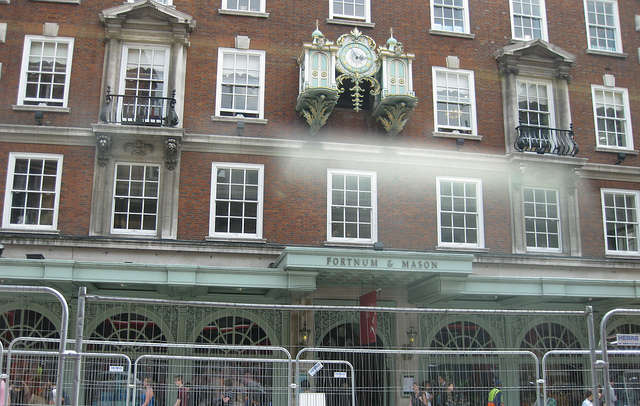Identify the text displayed in this image. FORTNUM MASON 